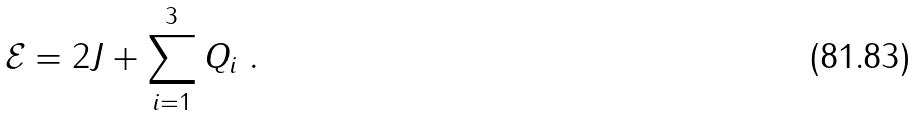Convert formula to latex. <formula><loc_0><loc_0><loc_500><loc_500>\mathcal { E } = 2 J + \sum _ { i = 1 } ^ { 3 } Q _ { i } \ .</formula> 